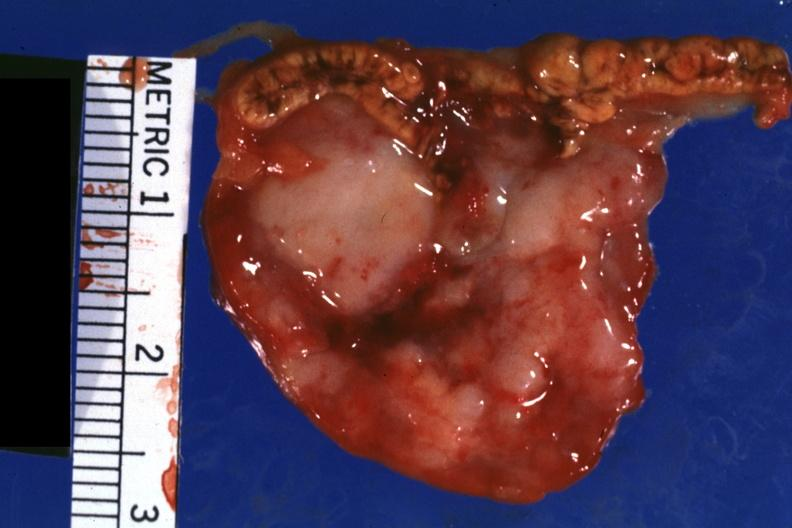s adrenal present?
Answer the question using a single word or phrase. Yes 